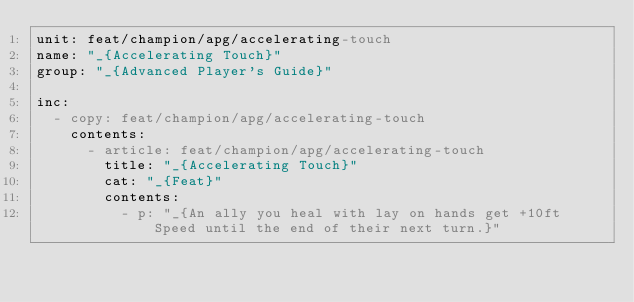<code> <loc_0><loc_0><loc_500><loc_500><_YAML_>unit: feat/champion/apg/accelerating-touch
name: "_{Accelerating Touch}"
group: "_{Advanced Player's Guide}"

inc:
  - copy: feat/champion/apg/accelerating-touch
    contents:
      - article: feat/champion/apg/accelerating-touch
        title: "_{Accelerating Touch}"
        cat: "_{Feat}"
        contents:
          - p: "_{An ally you heal with lay on hands get +10ft Speed until the end of their next turn.}"
</code> 